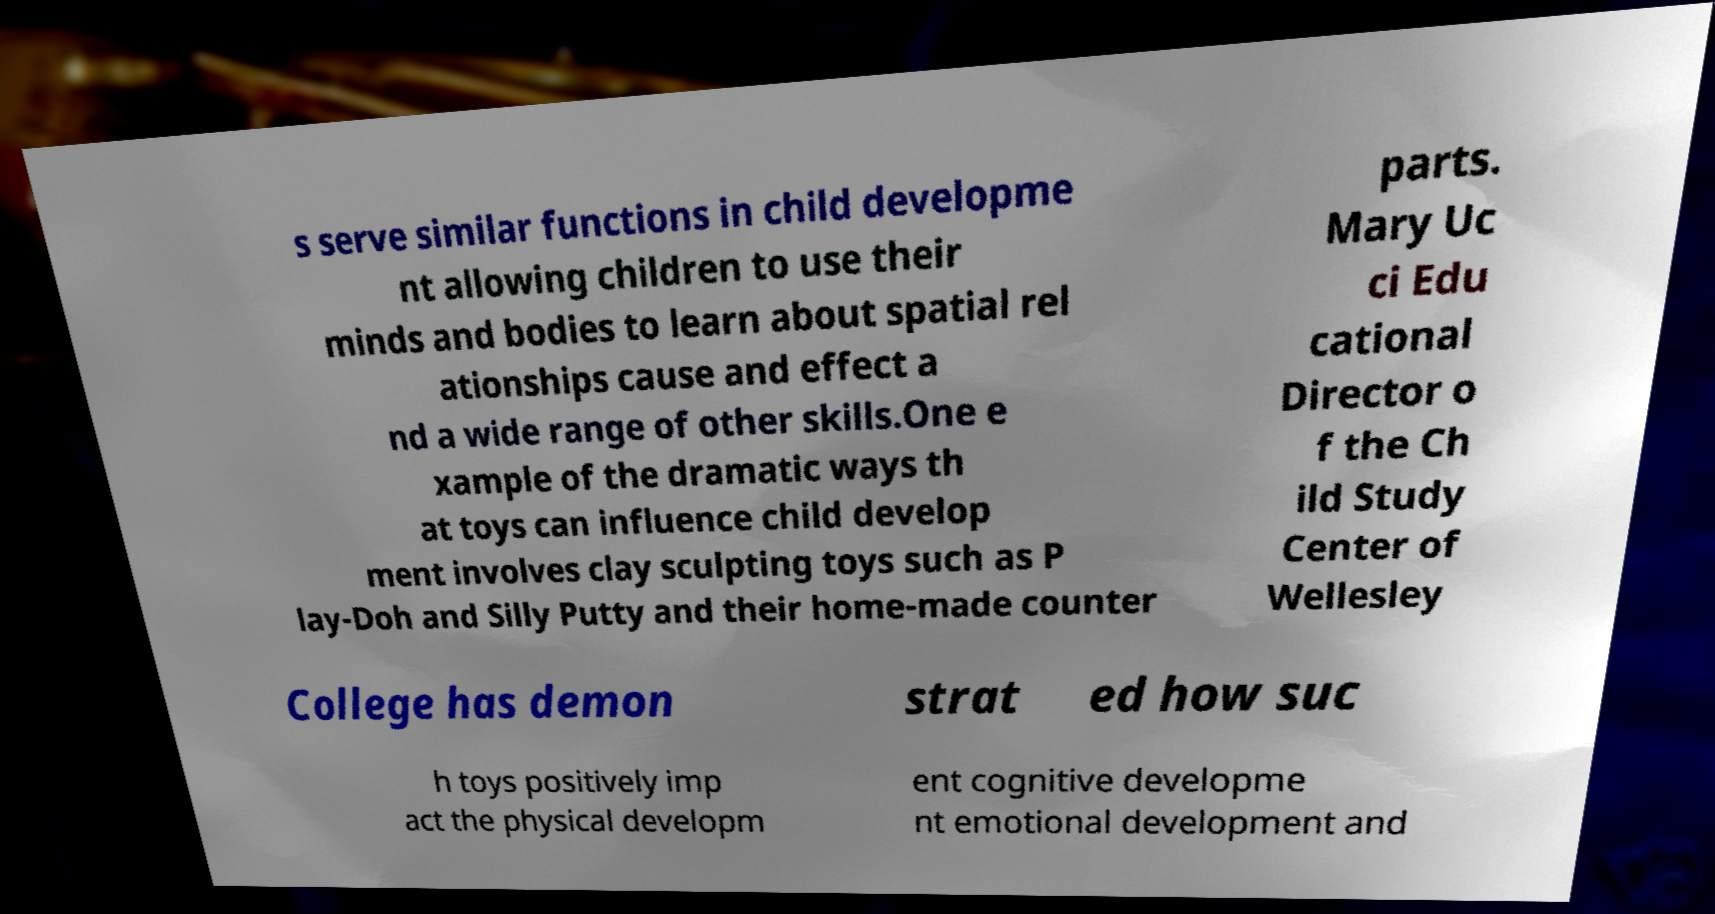Could you extract and type out the text from this image? s serve similar functions in child developme nt allowing children to use their minds and bodies to learn about spatial rel ationships cause and effect a nd a wide range of other skills.One e xample of the dramatic ways th at toys can influence child develop ment involves clay sculpting toys such as P lay-Doh and Silly Putty and their home-made counter parts. Mary Uc ci Edu cational Director o f the Ch ild Study Center of Wellesley College has demon strat ed how suc h toys positively imp act the physical developm ent cognitive developme nt emotional development and 